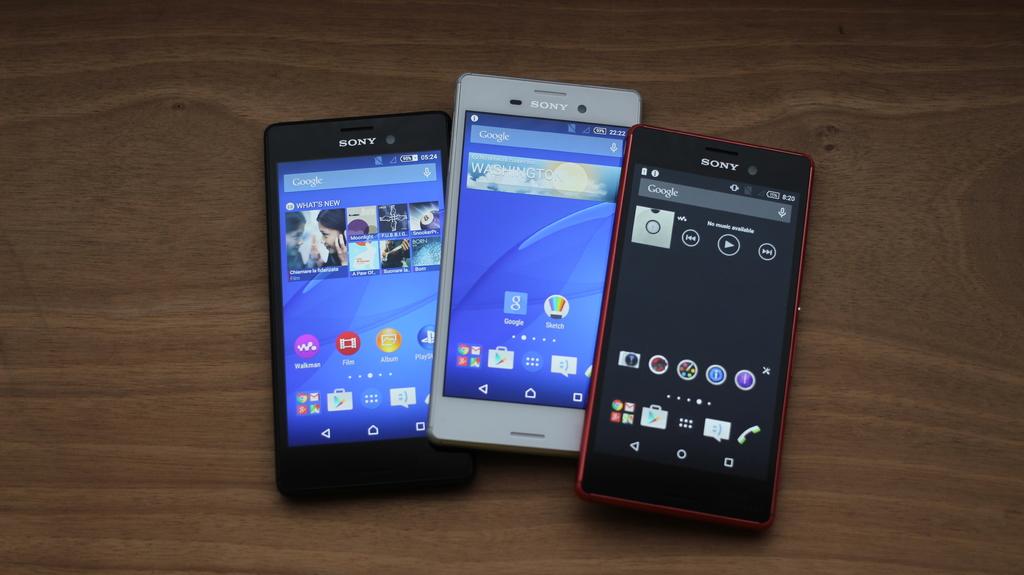What brand of phone is shown?
Offer a very short reply. Sony. What time does the black cell have?
Your response must be concise. Unanswerable. 